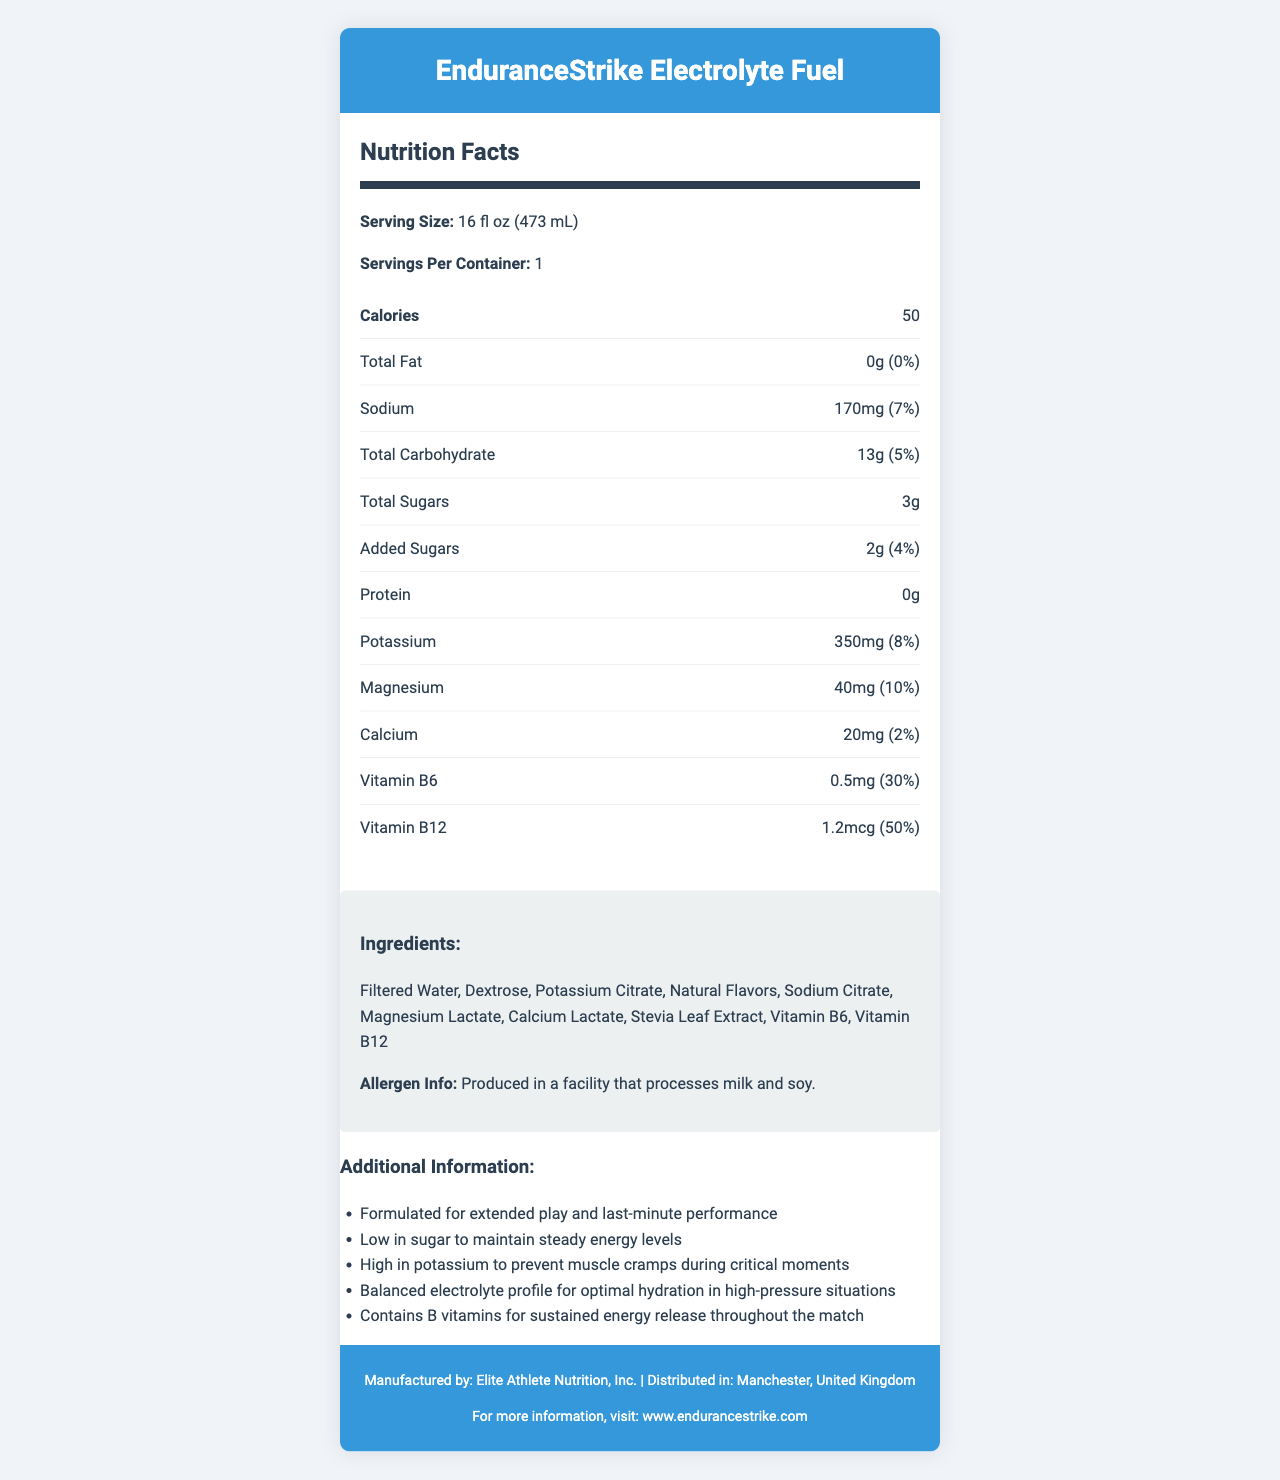what is the serving size? The serving size is listed directly in the document under the "Serving Size" section.
Answer: 16 fl oz (473 mL) what is the total carbohydrate content per serving? The total carbohydrate content is specified in the document under the "Total Carbohydrate" section.
Answer: 13g how much sodium does one serving contain? The amount of sodium per serving is indicated in the "Sodium" section of the document.
Answer: 170mg which ingredient is used as a sweetener in the drink? The ingredients list includes "Stevia Leaf Extract," which is a known sweetener.
Answer: Stevia Leaf Extract what percentage of the daily value for vitamin B12 does the drink provide? The document states that the drink provides 50% of the daily value for vitamin B12.
Answer: 50% how many calories are in one serving of the drink? The number of calories per serving is stated directly under the "Calories" section in the document.
Answer: 50 which of these vitamins is present in the highest daily value percentage? A. Vitamin B6 B. Vitamin B12 C. Vitamin C D. Vitamin D The document indicates that Vitamin B12 has a daily value percentage of 50%, which is the highest among the listed vitamins.
Answer: B. Vitamin B12 what is the correct serving size in fluid ounces? A. 8 fl oz B. 12 fl oz C. 16 fl oz D. 24 fl oz According to the document, the serving size is 16 fl oz. This is an easy fact to locate.
Answer: C. 16 fl oz is this product high in potassium? The document mentions that the product is high in potassium and specifies that it contains 350mg per serving (8% daily value), which supports optimal hydration and prevents muscle cramps.
Answer: Yes describe the main idea of the document. The description encapsulates the detailed breakdown of the nutrition facts, benefits, purpose, ingredients, and manufacturing and distribution information provided in the document.
Answer: The document provides the nutrition facts and additional information for "EnduranceStrike Electrolyte Fuel," a hydration sports drink designed for extended play. It highlights key features such as low sugar content, high potassium and B vitamins for sustained energy, and a balanced electrolyte profile. It includes details on serving size, nutrition information, ingredients, and manufacturer details. where is the product distributed? The distribution location is specified at the bottom of the document under the "Distributed in" section.
Answer: Manchester, United Kingdom what is the role of potassium in this drink? Potassium is highlighted in the document as being beneficial for preventing muscle cramps, especially important during extended play.
Answer: To prevent muscle cramps during critical moments how much protein is contained in one serving? The document states that the protein content per serving is 0g.
Answer: 0g does the drink contain any form of sugar? The document specifies that the drink contains 3g of total sugars, including 2g of added sugars.
Answer: Yes what is the address of the manufacturing facility? The document lists the manufacturer as "Elite Athlete Nutrition, Inc." and the distribution location as "Manchester, United Kingdom," but it does not provide a specific address.
Answer: Not enough information 